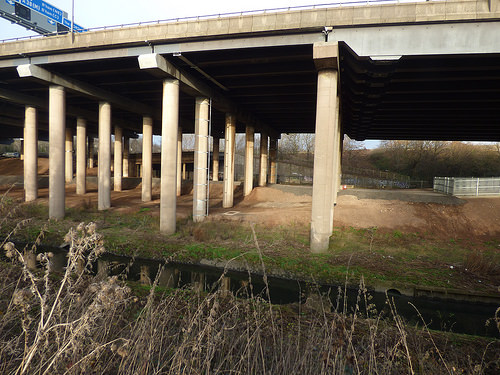<image>
Can you confirm if the gantry is on the pillar? No. The gantry is not positioned on the pillar. They may be near each other, but the gantry is not supported by or resting on top of the pillar. 